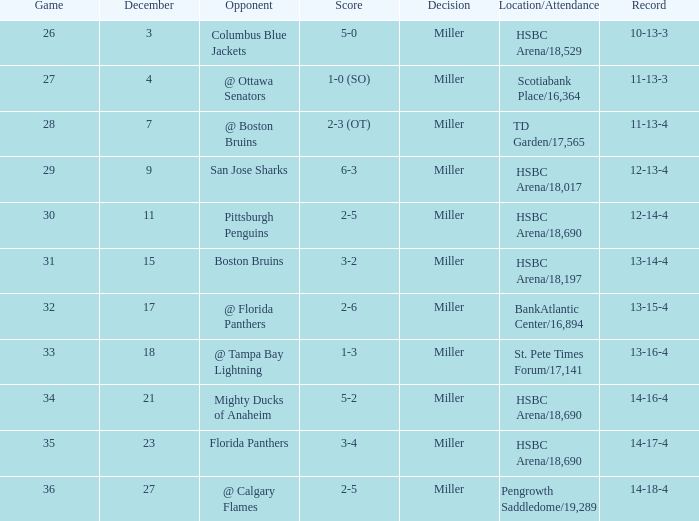Identify the smallest december for hsbc arena/18,01 9.0. Would you be able to parse every entry in this table? {'header': ['Game', 'December', 'Opponent', 'Score', 'Decision', 'Location/Attendance', 'Record'], 'rows': [['26', '3', 'Columbus Blue Jackets', '5-0', 'Miller', 'HSBC Arena/18,529', '10-13-3'], ['27', '4', '@ Ottawa Senators', '1-0 (SO)', 'Miller', 'Scotiabank Place/16,364', '11-13-3'], ['28', '7', '@ Boston Bruins', '2-3 (OT)', 'Miller', 'TD Garden/17,565', '11-13-4'], ['29', '9', 'San Jose Sharks', '6-3', 'Miller', 'HSBC Arena/18,017', '12-13-4'], ['30', '11', 'Pittsburgh Penguins', '2-5', 'Miller', 'HSBC Arena/18,690', '12-14-4'], ['31', '15', 'Boston Bruins', '3-2', 'Miller', 'HSBC Arena/18,197', '13-14-4'], ['32', '17', '@ Florida Panthers', '2-6', 'Miller', 'BankAtlantic Center/16,894', '13-15-4'], ['33', '18', '@ Tampa Bay Lightning', '1-3', 'Miller', 'St. Pete Times Forum/17,141', '13-16-4'], ['34', '21', 'Mighty Ducks of Anaheim', '5-2', 'Miller', 'HSBC Arena/18,690', '14-16-4'], ['35', '23', 'Florida Panthers', '3-4', 'Miller', 'HSBC Arena/18,690', '14-17-4'], ['36', '27', '@ Calgary Flames', '2-5', 'Miller', 'Pengrowth Saddledome/19,289', '14-18-4']]} 